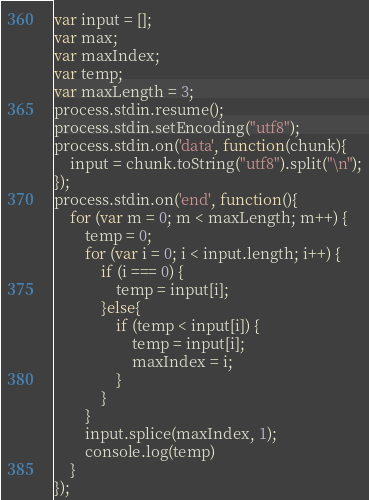<code> <loc_0><loc_0><loc_500><loc_500><_JavaScript_>var input = [];
var max;
var maxIndex;
var temp;
var maxLength = 3;
process.stdin.resume();
process.stdin.setEncoding("utf8");
process.stdin.on('data', function(chunk){
    input = chunk.toString("utf8").split("\n");
});
process.stdin.on('end', function(){
    for (var m = 0; m < maxLength; m++) {
        temp = 0;
        for (var i = 0; i < input.length; i++) {
            if (i === 0) {
                temp = input[i];
            }else{
                if (temp < input[i]) {
                    temp = input[i];
                    maxIndex = i;
                }
            }
        }
        input.splice(maxIndex, 1);
        console.log(temp)
    }
});</code> 